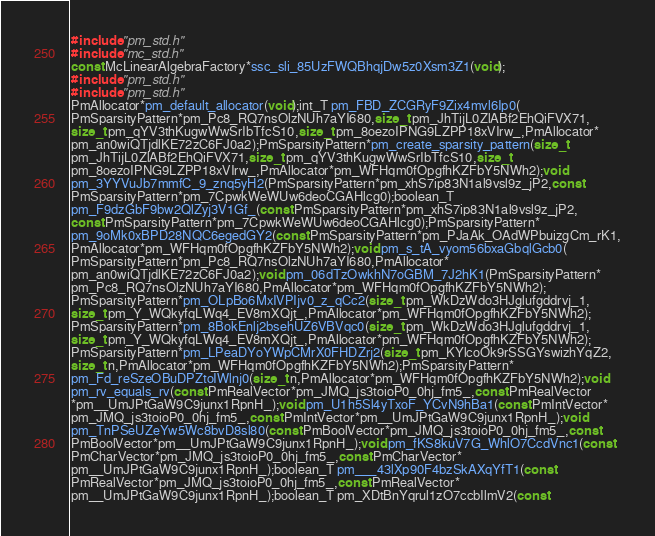Convert code to text. <code><loc_0><loc_0><loc_500><loc_500><_C_>#include "pm_std.h"
#include "mc_std.h"
const McLinearAlgebraFactory*ssc_sli_85UzFWQBhqjDw5z0Xsm3Z1(void);
#include "pm_std.h"
#include "pm_std.h"
PmAllocator*pm_default_allocator(void);int_T pm_FBD_ZCGRyF9Zix4mvl6Ip0(
PmSparsityPattern*pm_Pc8_RQ7nsOlzNUh7aYI680,size_t pm_JhTijL0ZlABf2EhQiFVX71,
size_t pm_qYV3thKugwWwSrIbTfcS10,size_t pm_8oezoIPNG9LZPP18xVIrw_,PmAllocator*
pm_an0wiQTjdlKE72zC6FJ0a2);PmSparsityPattern*pm_create_sparsity_pattern(size_t
pm_JhTijL0ZlABf2EhQiFVX71,size_t pm_qYV3thKugwWwSrIbTfcS10,size_t
pm_8oezoIPNG9LZPP18xVIrw_,PmAllocator*pm_WFHqm0fOpgfhKZFbY5NWh2);void
pm_3YYVuJb7mmfC_9_znq5yH2(PmSparsityPattern*pm_xhS7ip83N1al9vsl9z_jP2,const
PmSparsityPattern*pm_7CpwkWeWUw6deoCGAHlcg0);boolean_T
pm_F9dzGbF9bw2QlZyj3V1Gf_(const PmSparsityPattern*pm_xhS7ip83N1al9vsl9z_jP2,
const PmSparsityPattern*pm_7CpwkWeWUw6deoCGAHlcg0);PmSparsityPattern*
pm_9oMk0xBPD28NQC6egedGY2(const PmSparsityPattern*pm_PJaAk_OAdWPbuizgCm_rK1,
PmAllocator*pm_WFHqm0fOpgfhKZFbY5NWh2);void pm_s_tA_vyom56bxaGbqlGcb0(
PmSparsityPattern*pm_Pc8_RQ7nsOlzNUh7aYI680,PmAllocator*
pm_an0wiQTjdlKE72zC6FJ0a2);void pm_06dTzOwkhN7oGBM_7J2hK1(PmSparsityPattern*
pm_Pc8_RQ7nsOlzNUh7aYI680,PmAllocator*pm_WFHqm0fOpgfhKZFbY5NWh2);
PmSparsityPattern*pm_OLpBo6MxIVPIjv0_z_qCc2(size_t pm_WkDzWdo3HJglufgddrvj_1,
size_t pm_Y_WQkyfqLWq4_EV8mXQjt_,PmAllocator*pm_WFHqm0fOpgfhKZFbY5NWh2);
PmSparsityPattern*pm_8BokEnlj2bsehUZ6VBVqc0(size_t pm_WkDzWdo3HJglufgddrvj_1,
size_t pm_Y_WQkyfqLWq4_EV8mXQjt_,PmAllocator*pm_WFHqm0fOpgfhKZFbY5NWh2);
PmSparsityPattern*pm_LPeaDYoYWpCMrX0FHDZrj2(size_t pm_KYlcoOk9rSSGYswizhYqZ2,
size_t n,PmAllocator*pm_WFHqm0fOpgfhKZFbY5NWh2);PmSparsityPattern*
pm_Fd_reSzeOBuDPZtoIWlnj0(size_t n,PmAllocator*pm_WFHqm0fOpgfhKZFbY5NWh2);void
pm_rv_equals_rv(const PmRealVector*pm_JMQ_js3toioP0_0hj_fm5_,const PmRealVector
*pm__UmJPtGaW9C9junx1RpnH_);void pm_U1h5Sl4yTxoF_YCvN9hBa1(const PmIntVector*
pm_JMQ_js3toioP0_0hj_fm5_,const PmIntVector*pm__UmJPtGaW9C9junx1RpnH_);void
pm_TnPSeUZeYw5Wc8bvD8sl80(const PmBoolVector*pm_JMQ_js3toioP0_0hj_fm5_,const
PmBoolVector*pm__UmJPtGaW9C9junx1RpnH_);void pm_fKS8kuV7G_WhlO7CcdVnc1(const
PmCharVector*pm_JMQ_js3toioP0_0hj_fm5_,const PmCharVector*
pm__UmJPtGaW9C9junx1RpnH_);boolean_T pm___43lXp90F4bzSkAXqYfT1(const
PmRealVector*pm_JMQ_js3toioP0_0hj_fm5_,const PmRealVector*
pm__UmJPtGaW9C9junx1RpnH_);boolean_T pm_XDtBnYqrul1zO7ccbIlmV2(const</code> 